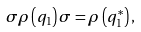Convert formula to latex. <formula><loc_0><loc_0><loc_500><loc_500>\sigma \rho \left ( q _ { 1 } \right ) \sigma = \rho \left ( q _ { 1 } ^ { \ast } \right ) ,</formula> 